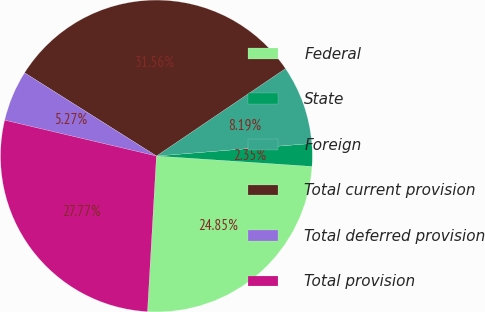Convert chart to OTSL. <chart><loc_0><loc_0><loc_500><loc_500><pie_chart><fcel>Federal<fcel>State<fcel>Foreign<fcel>Total current provision<fcel>Total deferred provision<fcel>Total provision<nl><fcel>24.85%<fcel>2.35%<fcel>8.19%<fcel>31.56%<fcel>5.27%<fcel>27.77%<nl></chart> 